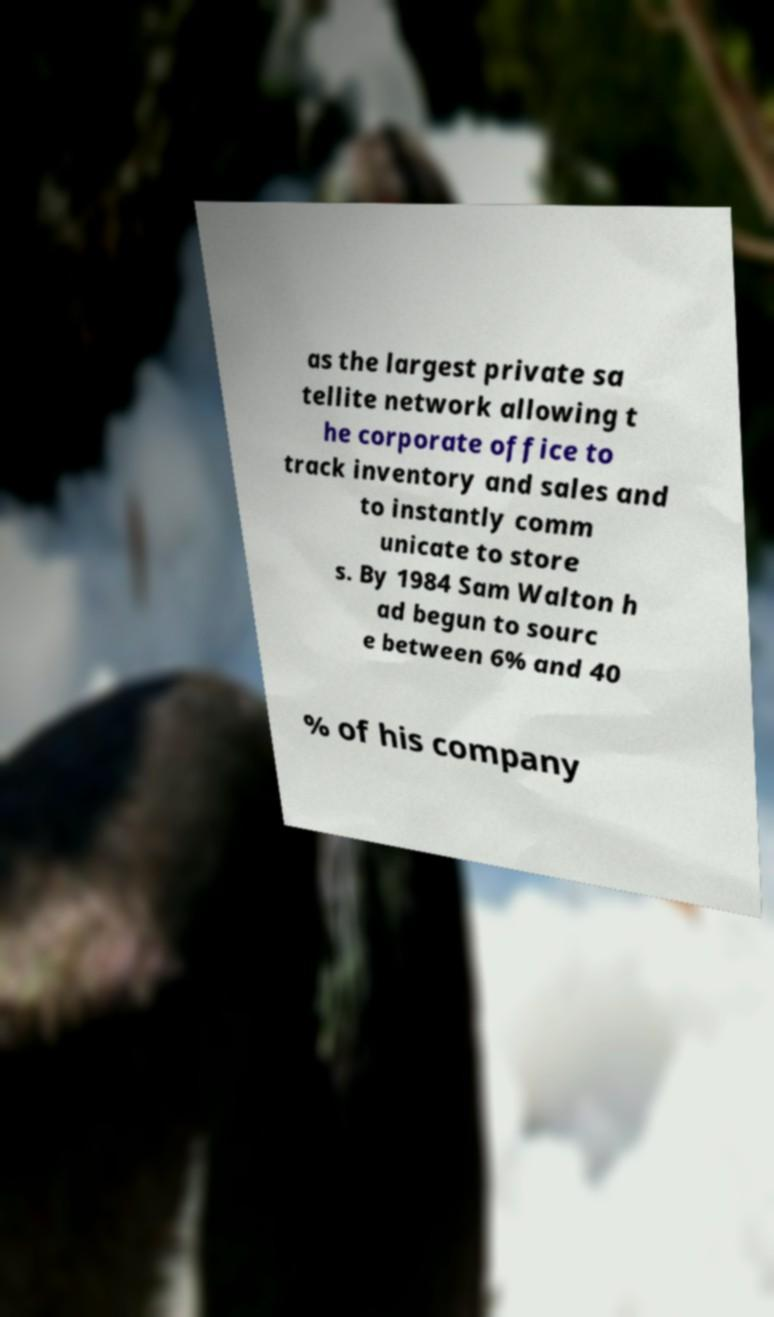Please identify and transcribe the text found in this image. as the largest private sa tellite network allowing t he corporate office to track inventory and sales and to instantly comm unicate to store s. By 1984 Sam Walton h ad begun to sourc e between 6% and 40 % of his company 